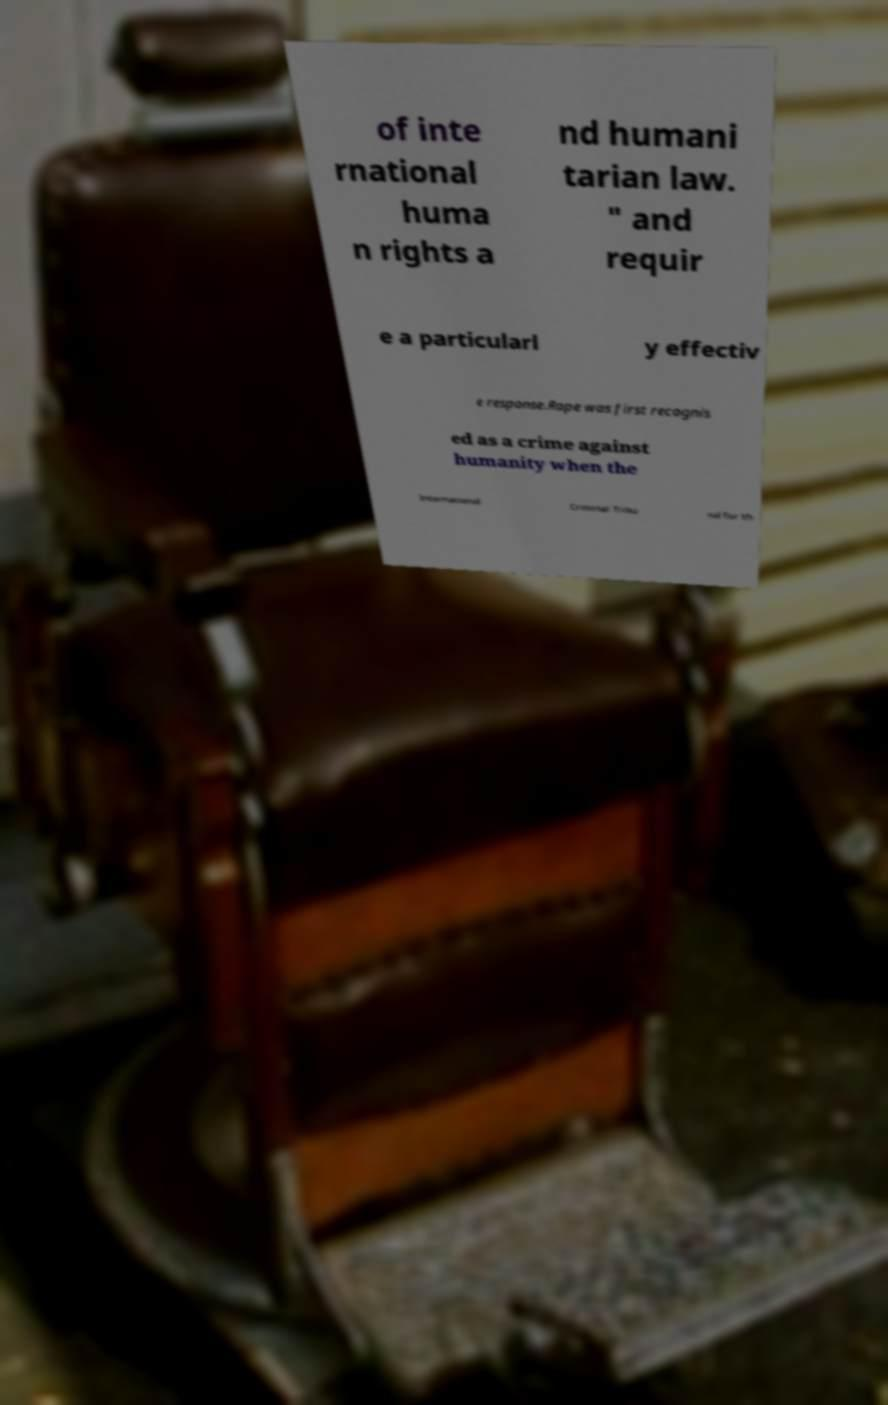Could you assist in decoding the text presented in this image and type it out clearly? of inte rnational huma n rights a nd humani tarian law. " and requir e a particularl y effectiv e response.Rape was first recognis ed as a crime against humanity when the International Criminal Tribu nal for th 